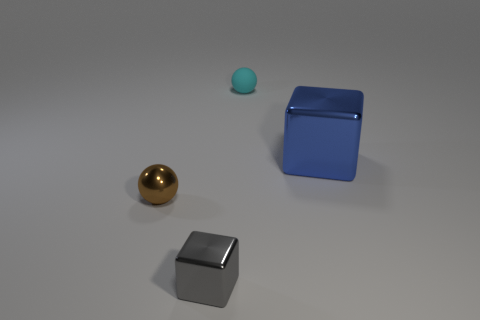There is a blue cube that is made of the same material as the brown thing; what is its size?
Your response must be concise. Large. Is the size of the blue metal block the same as the thing left of the gray shiny thing?
Keep it short and to the point. No. What is the color of the shiny thing that is both behind the gray cube and on the left side of the tiny rubber object?
Offer a very short reply. Brown. How many objects are metallic things in front of the blue shiny object or metallic objects in front of the large blue thing?
Offer a very short reply. 2. What color is the cube behind the metal block that is on the left side of the small sphere that is behind the big blue object?
Your response must be concise. Blue. Is there another rubber object of the same shape as the tiny rubber thing?
Offer a very short reply. No. What number of large shiny blocks are there?
Provide a succinct answer. 1. The large blue object is what shape?
Make the answer very short. Cube. How many blue cubes have the same size as the cyan matte sphere?
Provide a short and direct response. 0. Does the brown shiny thing have the same shape as the gray metal object?
Offer a very short reply. No. 